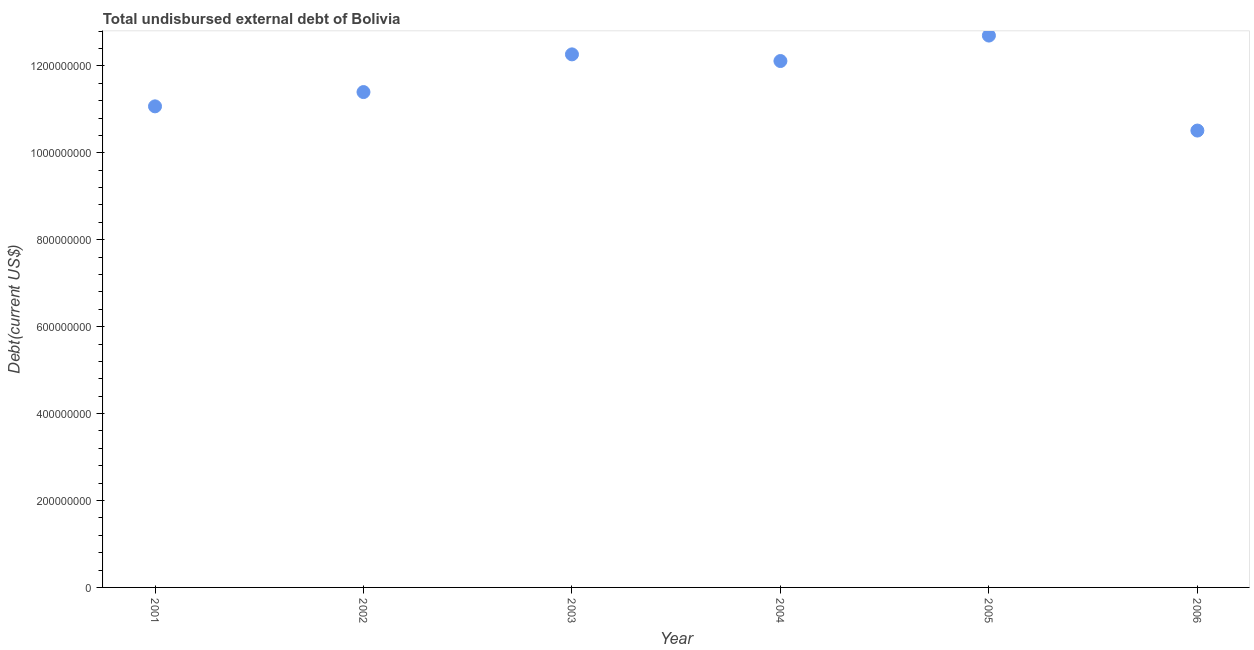What is the total debt in 2006?
Offer a terse response. 1.05e+09. Across all years, what is the maximum total debt?
Provide a short and direct response. 1.27e+09. Across all years, what is the minimum total debt?
Your response must be concise. 1.05e+09. In which year was the total debt minimum?
Offer a very short reply. 2006. What is the sum of the total debt?
Give a very brief answer. 7.01e+09. What is the difference between the total debt in 2005 and 2006?
Your answer should be very brief. 2.19e+08. What is the average total debt per year?
Your answer should be compact. 1.17e+09. What is the median total debt?
Your answer should be very brief. 1.18e+09. In how many years, is the total debt greater than 240000000 US$?
Your response must be concise. 6. What is the ratio of the total debt in 2002 to that in 2003?
Keep it short and to the point. 0.93. Is the difference between the total debt in 2002 and 2006 greater than the difference between any two years?
Give a very brief answer. No. What is the difference between the highest and the second highest total debt?
Offer a terse response. 4.32e+07. Is the sum of the total debt in 2001 and 2006 greater than the maximum total debt across all years?
Offer a very short reply. Yes. What is the difference between the highest and the lowest total debt?
Provide a succinct answer. 2.19e+08. Does the total debt monotonically increase over the years?
Make the answer very short. No. How many years are there in the graph?
Offer a terse response. 6. What is the difference between two consecutive major ticks on the Y-axis?
Your answer should be very brief. 2.00e+08. Are the values on the major ticks of Y-axis written in scientific E-notation?
Make the answer very short. No. Does the graph contain any zero values?
Provide a succinct answer. No. What is the title of the graph?
Your response must be concise. Total undisbursed external debt of Bolivia. What is the label or title of the X-axis?
Provide a short and direct response. Year. What is the label or title of the Y-axis?
Make the answer very short. Debt(current US$). What is the Debt(current US$) in 2001?
Ensure brevity in your answer.  1.11e+09. What is the Debt(current US$) in 2002?
Provide a short and direct response. 1.14e+09. What is the Debt(current US$) in 2003?
Ensure brevity in your answer.  1.23e+09. What is the Debt(current US$) in 2004?
Make the answer very short. 1.21e+09. What is the Debt(current US$) in 2005?
Provide a succinct answer. 1.27e+09. What is the Debt(current US$) in 2006?
Your answer should be very brief. 1.05e+09. What is the difference between the Debt(current US$) in 2001 and 2002?
Offer a terse response. -3.29e+07. What is the difference between the Debt(current US$) in 2001 and 2003?
Your answer should be compact. -1.20e+08. What is the difference between the Debt(current US$) in 2001 and 2004?
Your answer should be very brief. -1.04e+08. What is the difference between the Debt(current US$) in 2001 and 2005?
Your response must be concise. -1.63e+08. What is the difference between the Debt(current US$) in 2001 and 2006?
Offer a terse response. 5.57e+07. What is the difference between the Debt(current US$) in 2002 and 2003?
Provide a short and direct response. -8.67e+07. What is the difference between the Debt(current US$) in 2002 and 2004?
Make the answer very short. -7.14e+07. What is the difference between the Debt(current US$) in 2002 and 2005?
Make the answer very short. -1.30e+08. What is the difference between the Debt(current US$) in 2002 and 2006?
Offer a very short reply. 8.86e+07. What is the difference between the Debt(current US$) in 2003 and 2004?
Offer a very short reply. 1.53e+07. What is the difference between the Debt(current US$) in 2003 and 2005?
Ensure brevity in your answer.  -4.32e+07. What is the difference between the Debt(current US$) in 2003 and 2006?
Offer a terse response. 1.75e+08. What is the difference between the Debt(current US$) in 2004 and 2005?
Keep it short and to the point. -5.86e+07. What is the difference between the Debt(current US$) in 2004 and 2006?
Make the answer very short. 1.60e+08. What is the difference between the Debt(current US$) in 2005 and 2006?
Keep it short and to the point. 2.19e+08. What is the ratio of the Debt(current US$) in 2001 to that in 2003?
Give a very brief answer. 0.9. What is the ratio of the Debt(current US$) in 2001 to that in 2004?
Offer a very short reply. 0.91. What is the ratio of the Debt(current US$) in 2001 to that in 2005?
Make the answer very short. 0.87. What is the ratio of the Debt(current US$) in 2001 to that in 2006?
Your answer should be compact. 1.05. What is the ratio of the Debt(current US$) in 2002 to that in 2003?
Make the answer very short. 0.93. What is the ratio of the Debt(current US$) in 2002 to that in 2004?
Give a very brief answer. 0.94. What is the ratio of the Debt(current US$) in 2002 to that in 2005?
Your answer should be very brief. 0.9. What is the ratio of the Debt(current US$) in 2002 to that in 2006?
Your answer should be very brief. 1.08. What is the ratio of the Debt(current US$) in 2003 to that in 2004?
Make the answer very short. 1.01. What is the ratio of the Debt(current US$) in 2003 to that in 2005?
Give a very brief answer. 0.97. What is the ratio of the Debt(current US$) in 2003 to that in 2006?
Your answer should be compact. 1.17. What is the ratio of the Debt(current US$) in 2004 to that in 2005?
Keep it short and to the point. 0.95. What is the ratio of the Debt(current US$) in 2004 to that in 2006?
Your response must be concise. 1.15. What is the ratio of the Debt(current US$) in 2005 to that in 2006?
Provide a short and direct response. 1.21. 